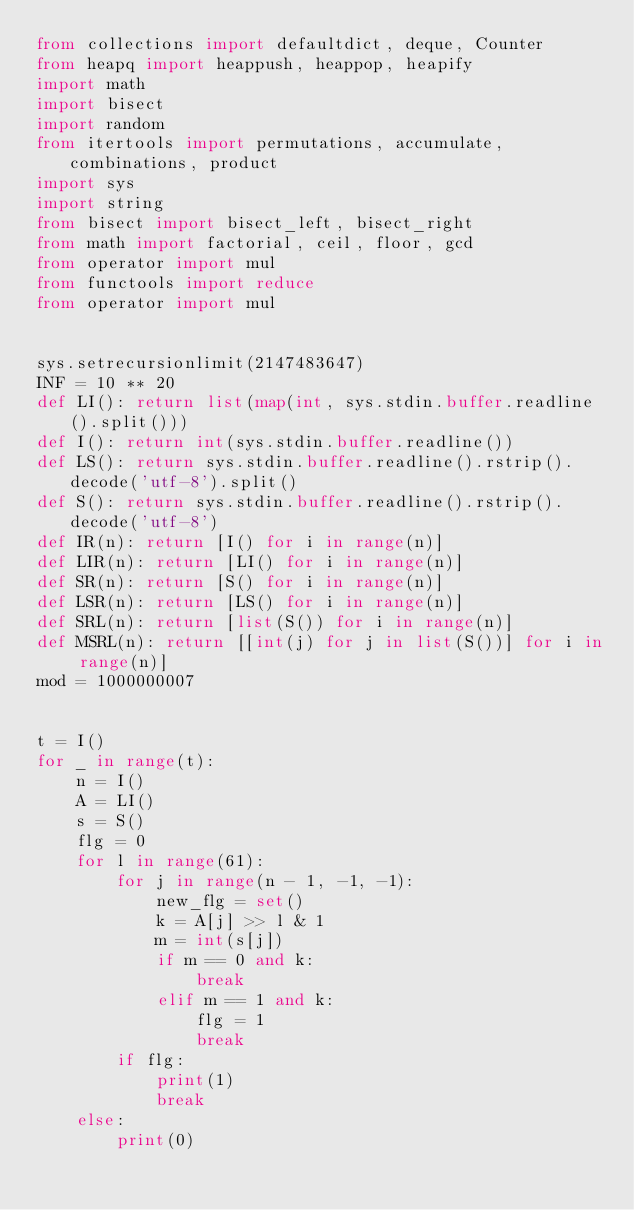Convert code to text. <code><loc_0><loc_0><loc_500><loc_500><_Python_>from collections import defaultdict, deque, Counter
from heapq import heappush, heappop, heapify
import math
import bisect
import random
from itertools import permutations, accumulate, combinations, product
import sys
import string
from bisect import bisect_left, bisect_right
from math import factorial, ceil, floor, gcd
from operator import mul
from functools import reduce
from operator import mul


sys.setrecursionlimit(2147483647)
INF = 10 ** 20
def LI(): return list(map(int, sys.stdin.buffer.readline().split()))
def I(): return int(sys.stdin.buffer.readline())
def LS(): return sys.stdin.buffer.readline().rstrip().decode('utf-8').split()
def S(): return sys.stdin.buffer.readline().rstrip().decode('utf-8')
def IR(n): return [I() for i in range(n)]
def LIR(n): return [LI() for i in range(n)]
def SR(n): return [S() for i in range(n)]
def LSR(n): return [LS() for i in range(n)]
def SRL(n): return [list(S()) for i in range(n)]
def MSRL(n): return [[int(j) for j in list(S())] for i in range(n)]
mod = 1000000007


t = I()
for _ in range(t):
    n = I()
    A = LI()
    s = S()
    flg = 0
    for l in range(61):
        for j in range(n - 1, -1, -1):
            new_flg = set()
            k = A[j] >> l & 1
            m = int(s[j])
            if m == 0 and k:
                break
            elif m == 1 and k:
                flg = 1
                break
        if flg:
            print(1)
            break
    else:
        print(0)










</code> 